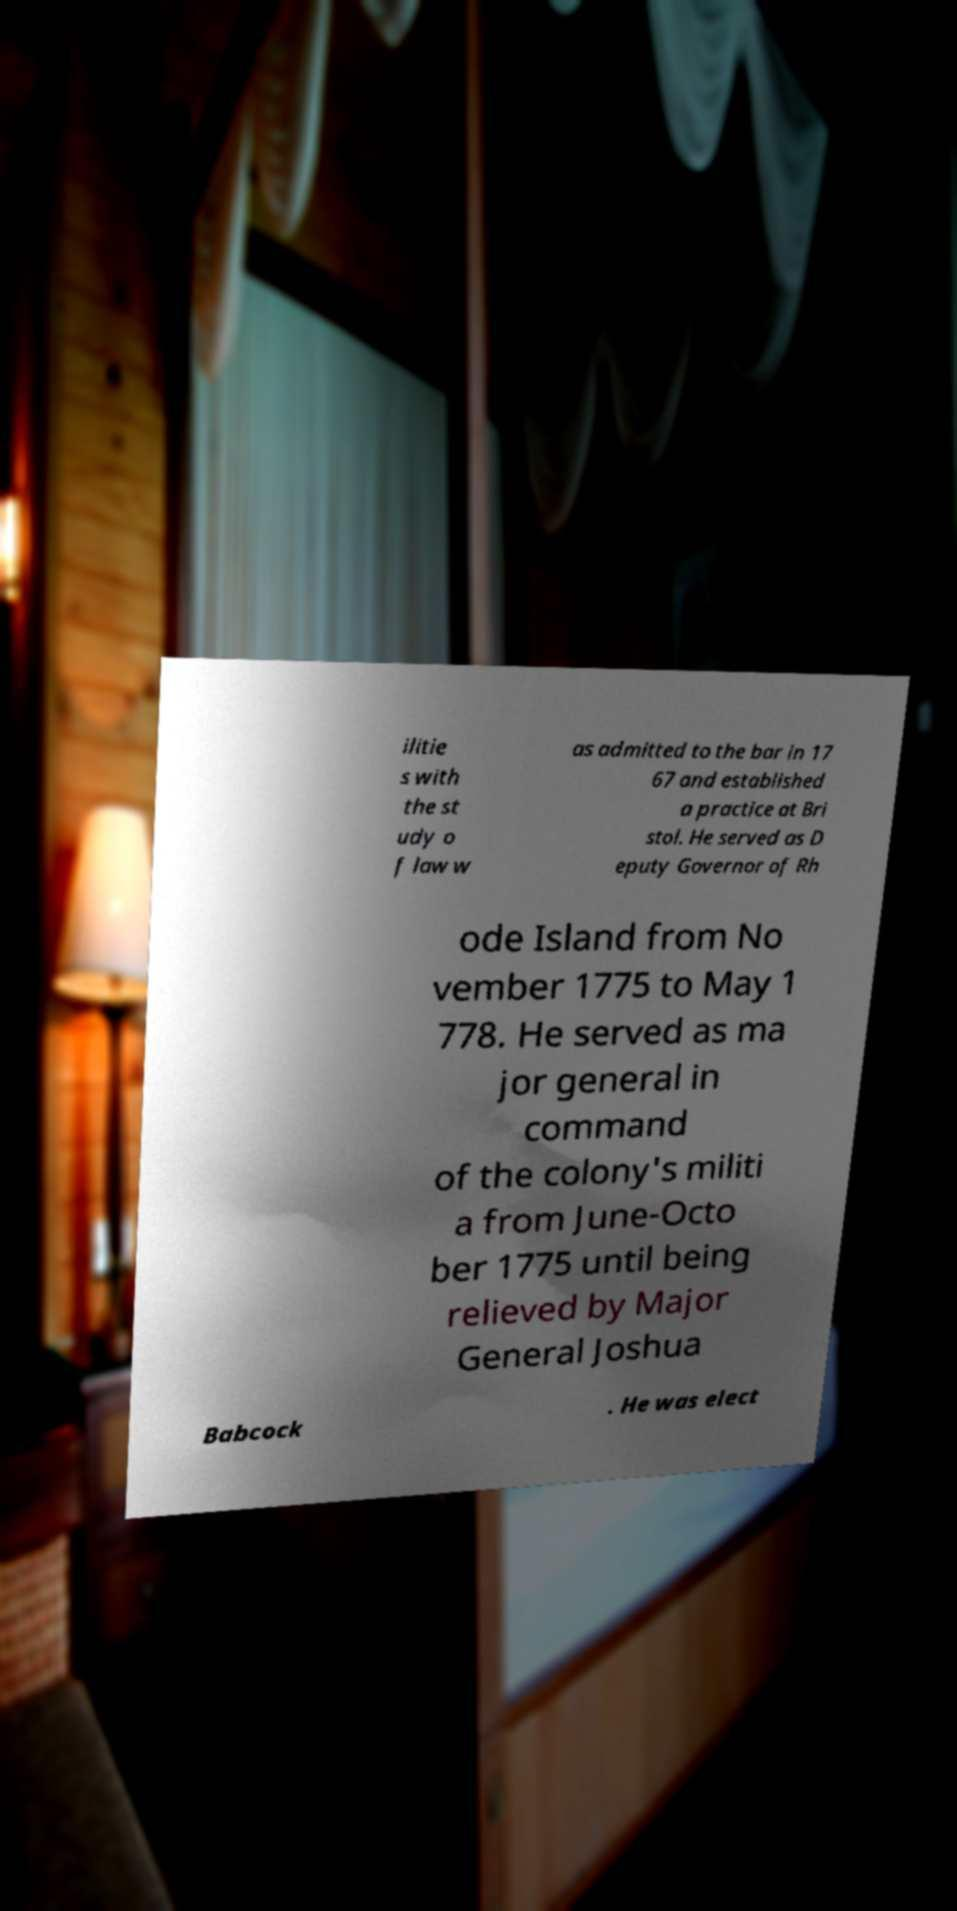What messages or text are displayed in this image? I need them in a readable, typed format. ilitie s with the st udy o f law w as admitted to the bar in 17 67 and established a practice at Bri stol. He served as D eputy Governor of Rh ode Island from No vember 1775 to May 1 778. He served as ma jor general in command of the colony's militi a from June-Octo ber 1775 until being relieved by Major General Joshua Babcock . He was elect 